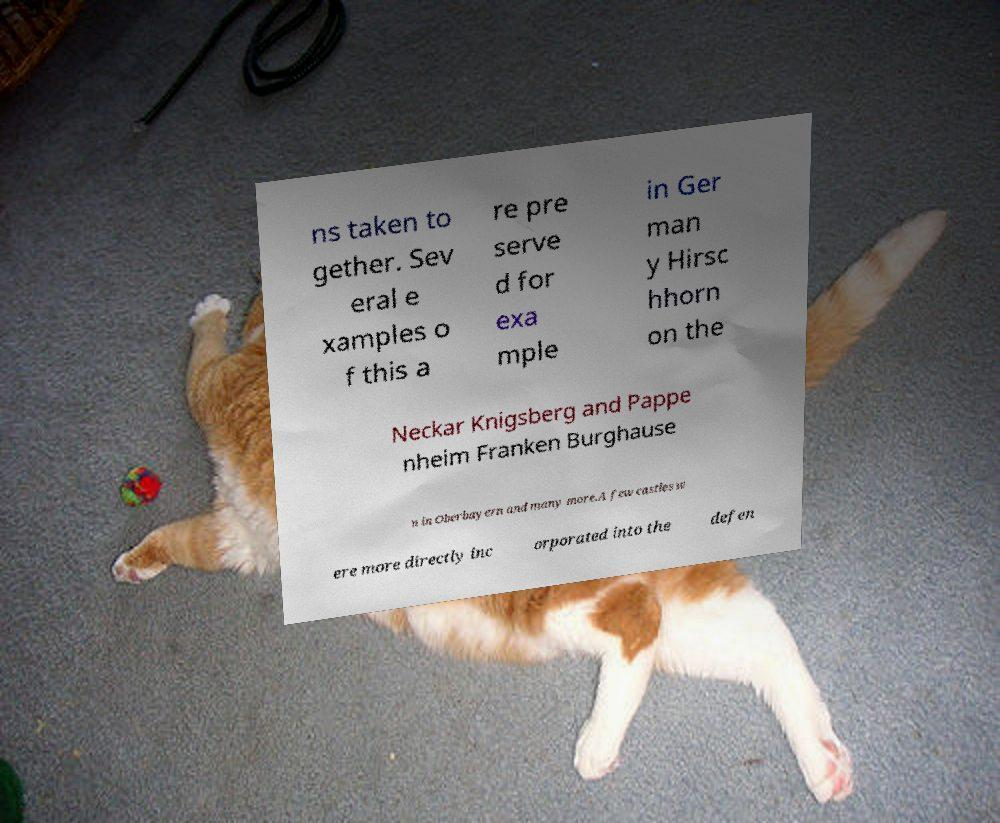Could you extract and type out the text from this image? ns taken to gether. Sev eral e xamples o f this a re pre serve d for exa mple in Ger man y Hirsc hhorn on the Neckar Knigsberg and Pappe nheim Franken Burghause n in Oberbayern and many more.A few castles w ere more directly inc orporated into the defen 